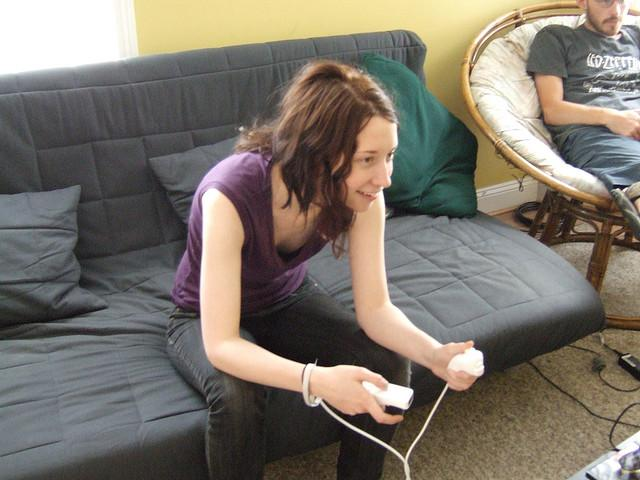What setting are these types of seating often seen in?

Choices:
A) apartment
B) church
C) mansion
D) office apartment 